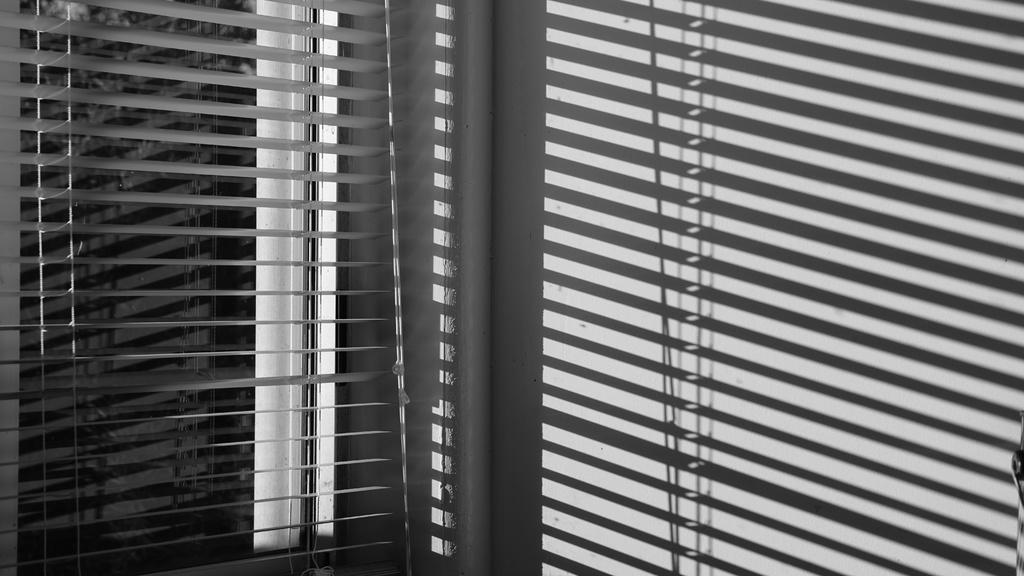Could you give a brief overview of what you see in this image? In the picture I can see window blinds. This picture is black and white in color. 